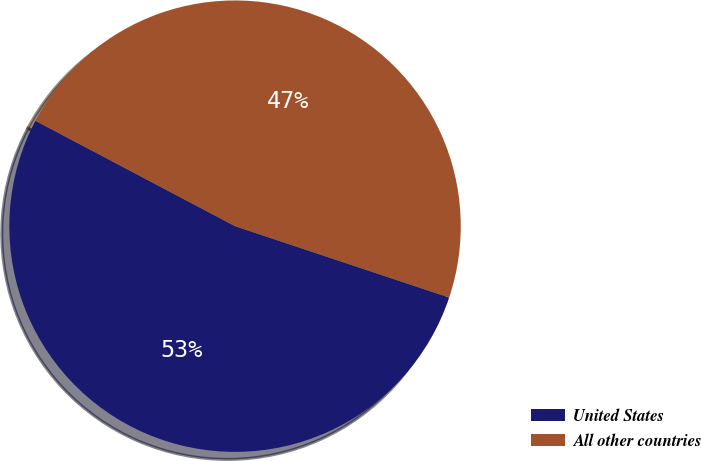<chart> <loc_0><loc_0><loc_500><loc_500><pie_chart><fcel>United States<fcel>All other countries<nl><fcel>52.61%<fcel>47.39%<nl></chart> 